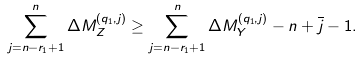Convert formula to latex. <formula><loc_0><loc_0><loc_500><loc_500>\sum _ { j = n - r _ { 1 } + 1 } ^ { n } \Delta M _ { Z } ^ { ( q _ { 1 } , j ) } \geq \sum _ { j = n - r _ { 1 } + 1 } ^ { n } \Delta M _ { Y } ^ { ( q _ { 1 } , j ) } - n + \overline { j } - 1 .</formula> 